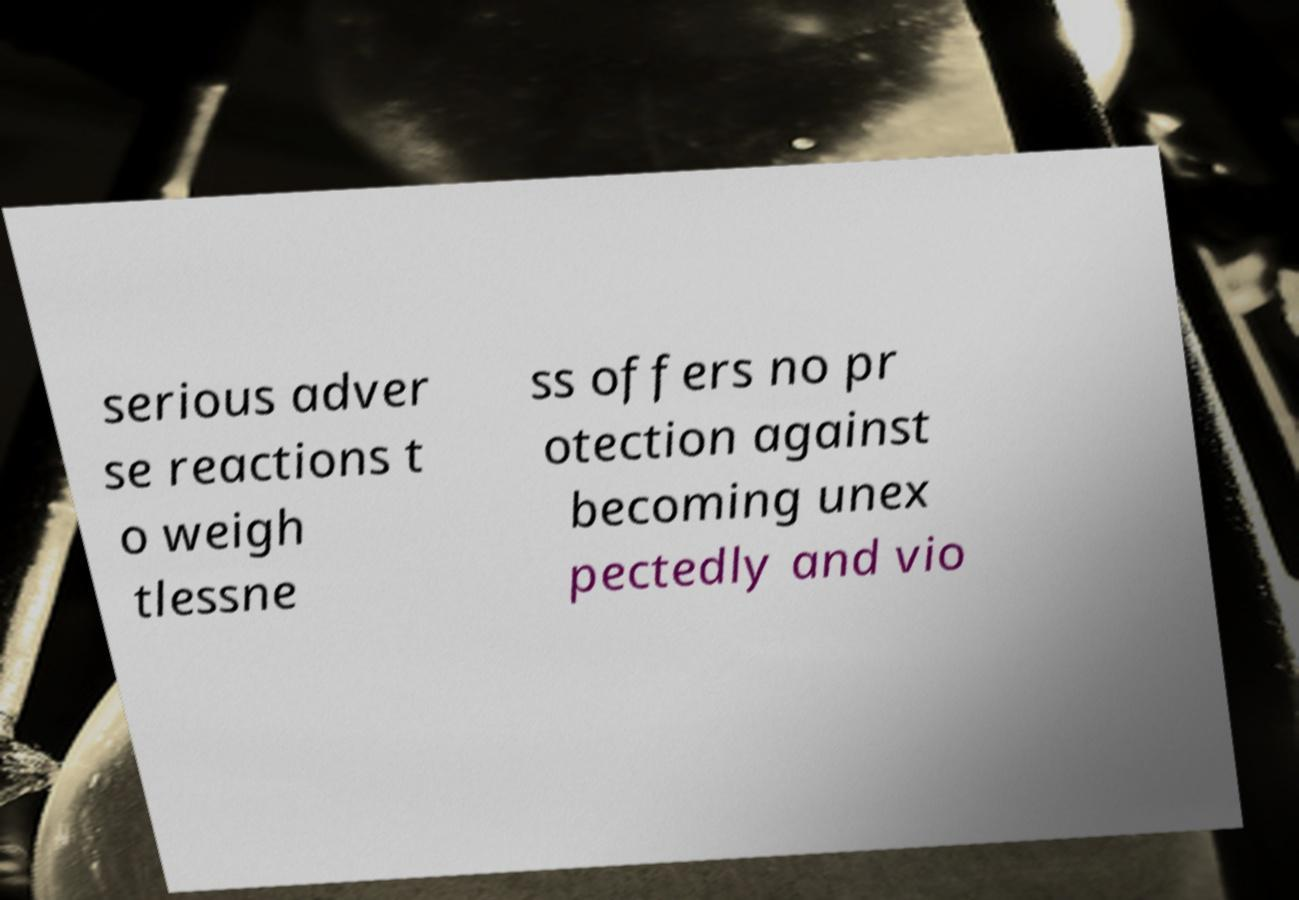There's text embedded in this image that I need extracted. Can you transcribe it verbatim? serious adver se reactions t o weigh tlessne ss offers no pr otection against becoming unex pectedly and vio 